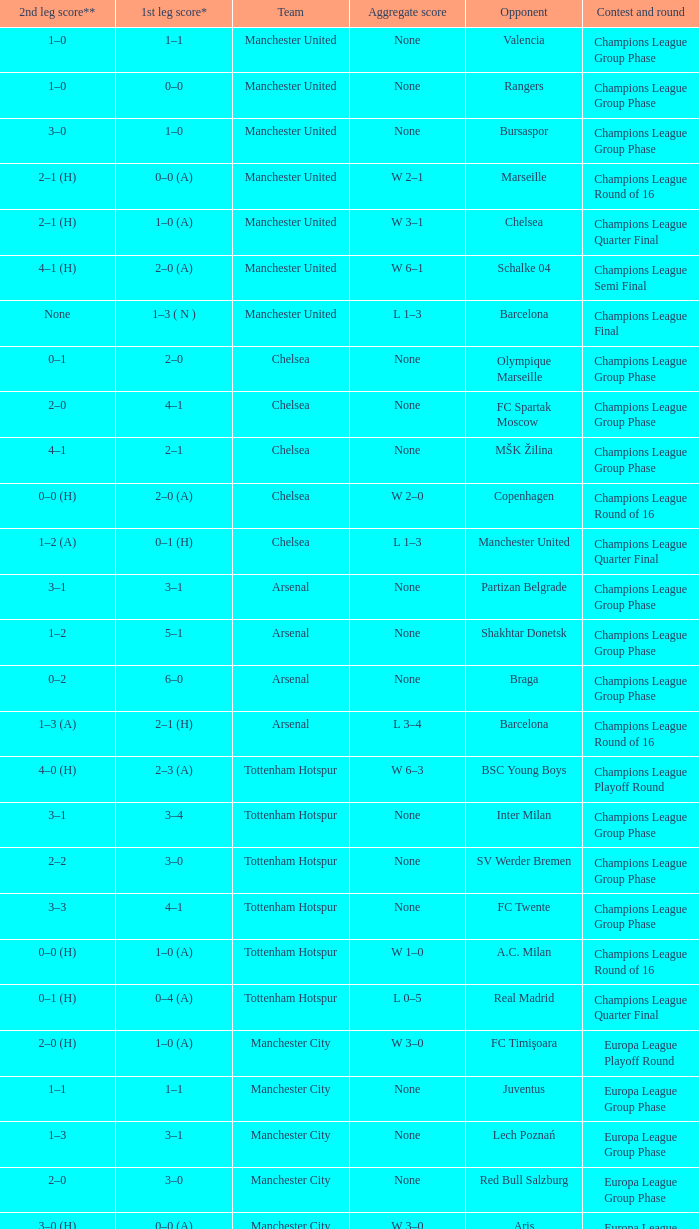How many goals did each one of the teams score in the first leg of the match between Liverpool and Trabzonspor? 1–0 (H). 